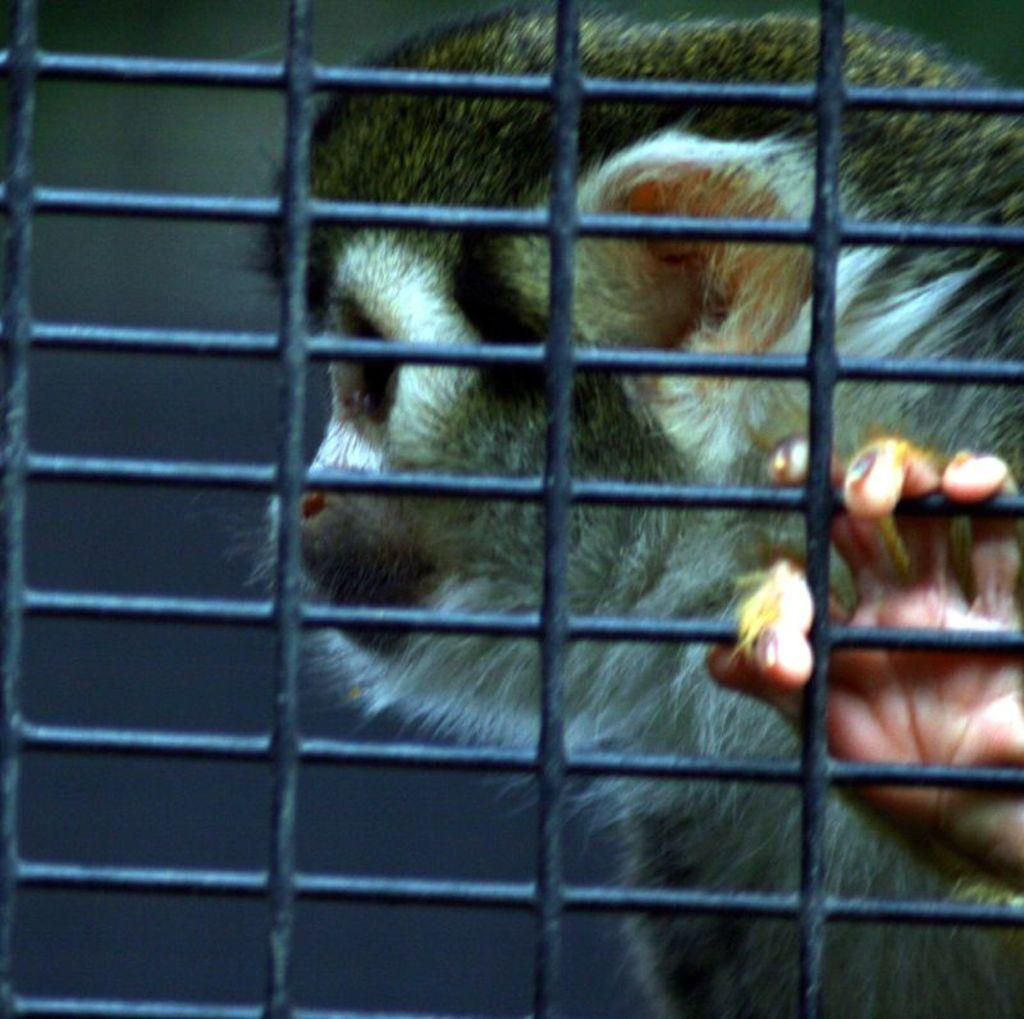What can be seen in the image that separates areas or provides a barrier? There is a fencing in the image. What is located behind the fencing in the image? There is an animal behind the fencing. What type of experience does the stone have in the image? There is no stone present in the image, so it cannot have any experience. 